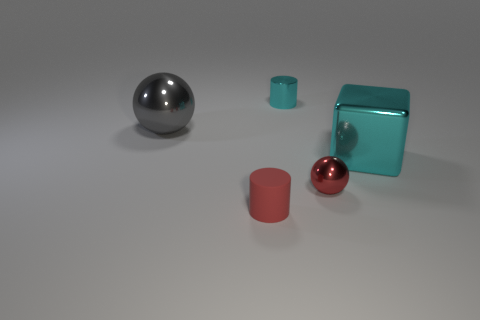What materials are the objects in the image made of, and which one appears the most reflective? The objects appear to be made of different materials. The large sphere seems quite reflective, suggesting it could be made of polished metal, which makes it the most reflective object in the scene. Is there any object that stands out due to its shape? Yes, the large teal cube stands out because of its distinct geometric shape and the fact that it is the only perfect cube in the scene. 